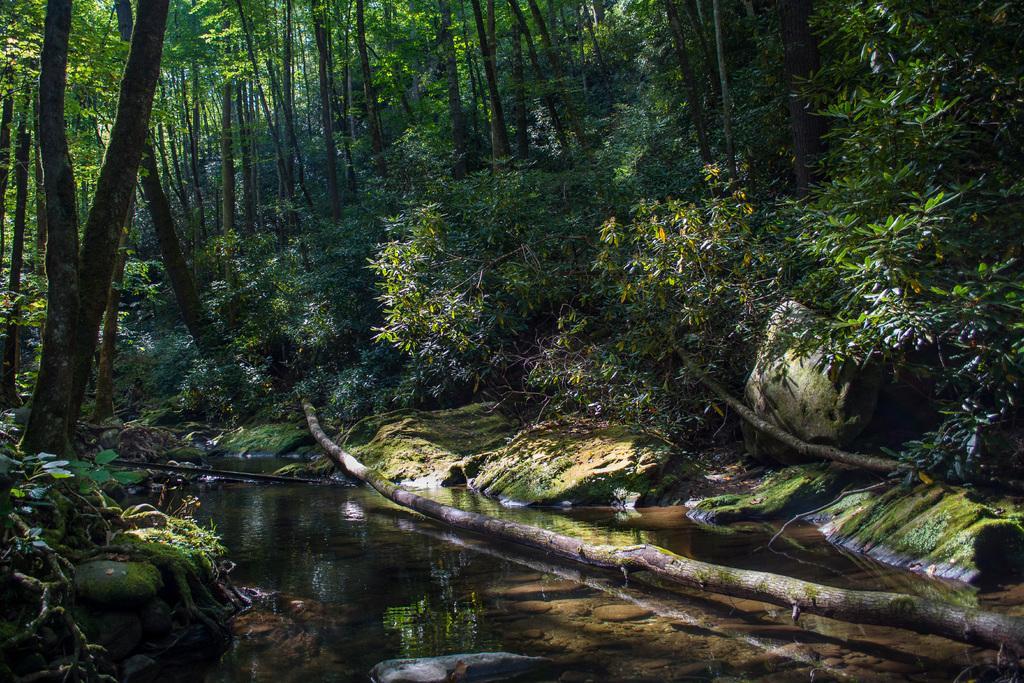Can you describe this image briefly? In this image there are trees and we can see logs. There are rocks. At the bottom there is water. 